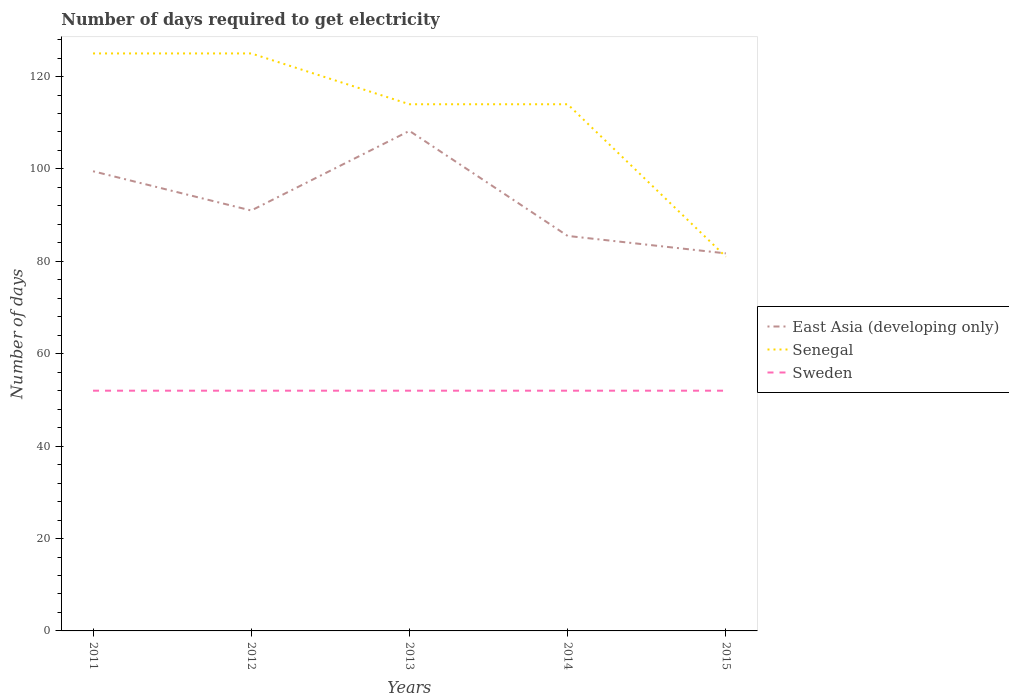How many different coloured lines are there?
Offer a very short reply. 3. Does the line corresponding to Sweden intersect with the line corresponding to Senegal?
Offer a terse response. No. Is the number of lines equal to the number of legend labels?
Ensure brevity in your answer.  Yes. Across all years, what is the maximum number of days required to get electricity in in Senegal?
Offer a very short reply. 81. What is the total number of days required to get electricity in in East Asia (developing only) in the graph?
Your answer should be very brief. 3.78. What is the difference between the highest and the second highest number of days required to get electricity in in Senegal?
Offer a terse response. 44. Is the number of days required to get electricity in in Senegal strictly greater than the number of days required to get electricity in in Sweden over the years?
Ensure brevity in your answer.  No. How many lines are there?
Make the answer very short. 3. Are the values on the major ticks of Y-axis written in scientific E-notation?
Provide a short and direct response. No. Does the graph contain any zero values?
Provide a succinct answer. No. Where does the legend appear in the graph?
Offer a terse response. Center right. What is the title of the graph?
Provide a short and direct response. Number of days required to get electricity. Does "Sri Lanka" appear as one of the legend labels in the graph?
Offer a very short reply. No. What is the label or title of the Y-axis?
Provide a succinct answer. Number of days. What is the Number of days of East Asia (developing only) in 2011?
Make the answer very short. 99.5. What is the Number of days of Senegal in 2011?
Your answer should be compact. 125. What is the Number of days in Sweden in 2011?
Offer a terse response. 52. What is the Number of days of East Asia (developing only) in 2012?
Offer a very short reply. 91. What is the Number of days in Senegal in 2012?
Your response must be concise. 125. What is the Number of days of Sweden in 2012?
Ensure brevity in your answer.  52. What is the Number of days in East Asia (developing only) in 2013?
Provide a short and direct response. 108.24. What is the Number of days of Senegal in 2013?
Your answer should be very brief. 114. What is the Number of days in Sweden in 2013?
Provide a succinct answer. 52. What is the Number of days of East Asia (developing only) in 2014?
Keep it short and to the point. 85.5. What is the Number of days in Senegal in 2014?
Ensure brevity in your answer.  114. What is the Number of days in Sweden in 2014?
Keep it short and to the point. 52. What is the Number of days of East Asia (developing only) in 2015?
Offer a very short reply. 81.72. What is the Number of days in Sweden in 2015?
Provide a succinct answer. 52. Across all years, what is the maximum Number of days of East Asia (developing only)?
Your response must be concise. 108.24. Across all years, what is the maximum Number of days of Senegal?
Your response must be concise. 125. Across all years, what is the maximum Number of days of Sweden?
Your answer should be very brief. 52. Across all years, what is the minimum Number of days in East Asia (developing only)?
Your answer should be compact. 81.72. Across all years, what is the minimum Number of days in Sweden?
Provide a short and direct response. 52. What is the total Number of days in East Asia (developing only) in the graph?
Provide a succinct answer. 465.96. What is the total Number of days of Senegal in the graph?
Offer a terse response. 559. What is the total Number of days of Sweden in the graph?
Offer a terse response. 260. What is the difference between the Number of days in East Asia (developing only) in 2011 and that in 2012?
Your response must be concise. 8.5. What is the difference between the Number of days of Senegal in 2011 and that in 2012?
Your answer should be very brief. 0. What is the difference between the Number of days in East Asia (developing only) in 2011 and that in 2013?
Your answer should be very brief. -8.74. What is the difference between the Number of days in Senegal in 2011 and that in 2013?
Keep it short and to the point. 11. What is the difference between the Number of days of East Asia (developing only) in 2011 and that in 2014?
Keep it short and to the point. 14. What is the difference between the Number of days in Senegal in 2011 and that in 2014?
Ensure brevity in your answer.  11. What is the difference between the Number of days of Sweden in 2011 and that in 2014?
Provide a short and direct response. 0. What is the difference between the Number of days in East Asia (developing only) in 2011 and that in 2015?
Your response must be concise. 17.78. What is the difference between the Number of days in Senegal in 2011 and that in 2015?
Provide a short and direct response. 44. What is the difference between the Number of days in Sweden in 2011 and that in 2015?
Provide a succinct answer. 0. What is the difference between the Number of days of East Asia (developing only) in 2012 and that in 2013?
Your answer should be very brief. -17.24. What is the difference between the Number of days in Senegal in 2012 and that in 2013?
Provide a succinct answer. 11. What is the difference between the Number of days in Sweden in 2012 and that in 2013?
Make the answer very short. 0. What is the difference between the Number of days in Senegal in 2012 and that in 2014?
Give a very brief answer. 11. What is the difference between the Number of days of East Asia (developing only) in 2012 and that in 2015?
Make the answer very short. 9.28. What is the difference between the Number of days in Sweden in 2012 and that in 2015?
Your response must be concise. 0. What is the difference between the Number of days in East Asia (developing only) in 2013 and that in 2014?
Your answer should be compact. 22.74. What is the difference between the Number of days of Senegal in 2013 and that in 2014?
Your answer should be compact. 0. What is the difference between the Number of days of Sweden in 2013 and that in 2014?
Offer a very short reply. 0. What is the difference between the Number of days in East Asia (developing only) in 2013 and that in 2015?
Provide a short and direct response. 26.51. What is the difference between the Number of days of East Asia (developing only) in 2014 and that in 2015?
Make the answer very short. 3.78. What is the difference between the Number of days in East Asia (developing only) in 2011 and the Number of days in Senegal in 2012?
Keep it short and to the point. -25.5. What is the difference between the Number of days of East Asia (developing only) in 2011 and the Number of days of Sweden in 2012?
Give a very brief answer. 47.5. What is the difference between the Number of days of Senegal in 2011 and the Number of days of Sweden in 2012?
Provide a succinct answer. 73. What is the difference between the Number of days of East Asia (developing only) in 2011 and the Number of days of Senegal in 2013?
Ensure brevity in your answer.  -14.5. What is the difference between the Number of days of East Asia (developing only) in 2011 and the Number of days of Sweden in 2013?
Ensure brevity in your answer.  47.5. What is the difference between the Number of days in East Asia (developing only) in 2011 and the Number of days in Senegal in 2014?
Keep it short and to the point. -14.5. What is the difference between the Number of days of East Asia (developing only) in 2011 and the Number of days of Sweden in 2014?
Your answer should be compact. 47.5. What is the difference between the Number of days in Senegal in 2011 and the Number of days in Sweden in 2014?
Your answer should be compact. 73. What is the difference between the Number of days in East Asia (developing only) in 2011 and the Number of days in Sweden in 2015?
Provide a short and direct response. 47.5. What is the difference between the Number of days of East Asia (developing only) in 2012 and the Number of days of Senegal in 2013?
Your answer should be very brief. -23. What is the difference between the Number of days in Senegal in 2012 and the Number of days in Sweden in 2013?
Offer a very short reply. 73. What is the difference between the Number of days in East Asia (developing only) in 2012 and the Number of days in Senegal in 2014?
Make the answer very short. -23. What is the difference between the Number of days in East Asia (developing only) in 2012 and the Number of days in Sweden in 2014?
Provide a succinct answer. 39. What is the difference between the Number of days of East Asia (developing only) in 2012 and the Number of days of Sweden in 2015?
Give a very brief answer. 39. What is the difference between the Number of days of Senegal in 2012 and the Number of days of Sweden in 2015?
Your answer should be very brief. 73. What is the difference between the Number of days in East Asia (developing only) in 2013 and the Number of days in Senegal in 2014?
Ensure brevity in your answer.  -5.76. What is the difference between the Number of days of East Asia (developing only) in 2013 and the Number of days of Sweden in 2014?
Offer a very short reply. 56.24. What is the difference between the Number of days in Senegal in 2013 and the Number of days in Sweden in 2014?
Your answer should be compact. 62. What is the difference between the Number of days in East Asia (developing only) in 2013 and the Number of days in Senegal in 2015?
Make the answer very short. 27.24. What is the difference between the Number of days in East Asia (developing only) in 2013 and the Number of days in Sweden in 2015?
Make the answer very short. 56.24. What is the difference between the Number of days of Senegal in 2013 and the Number of days of Sweden in 2015?
Provide a short and direct response. 62. What is the difference between the Number of days of East Asia (developing only) in 2014 and the Number of days of Sweden in 2015?
Your answer should be very brief. 33.5. What is the average Number of days of East Asia (developing only) per year?
Offer a very short reply. 93.19. What is the average Number of days in Senegal per year?
Your answer should be compact. 111.8. What is the average Number of days in Sweden per year?
Offer a very short reply. 52. In the year 2011, what is the difference between the Number of days of East Asia (developing only) and Number of days of Senegal?
Provide a succinct answer. -25.5. In the year 2011, what is the difference between the Number of days of East Asia (developing only) and Number of days of Sweden?
Your answer should be very brief. 47.5. In the year 2011, what is the difference between the Number of days of Senegal and Number of days of Sweden?
Offer a terse response. 73. In the year 2012, what is the difference between the Number of days of East Asia (developing only) and Number of days of Senegal?
Your answer should be compact. -34. In the year 2012, what is the difference between the Number of days of East Asia (developing only) and Number of days of Sweden?
Your answer should be very brief. 39. In the year 2013, what is the difference between the Number of days of East Asia (developing only) and Number of days of Senegal?
Ensure brevity in your answer.  -5.76. In the year 2013, what is the difference between the Number of days in East Asia (developing only) and Number of days in Sweden?
Your response must be concise. 56.24. In the year 2014, what is the difference between the Number of days of East Asia (developing only) and Number of days of Senegal?
Give a very brief answer. -28.5. In the year 2014, what is the difference between the Number of days in East Asia (developing only) and Number of days in Sweden?
Your response must be concise. 33.5. In the year 2014, what is the difference between the Number of days of Senegal and Number of days of Sweden?
Offer a very short reply. 62. In the year 2015, what is the difference between the Number of days in East Asia (developing only) and Number of days in Senegal?
Keep it short and to the point. 0.72. In the year 2015, what is the difference between the Number of days in East Asia (developing only) and Number of days in Sweden?
Your answer should be very brief. 29.72. In the year 2015, what is the difference between the Number of days of Senegal and Number of days of Sweden?
Offer a very short reply. 29. What is the ratio of the Number of days in East Asia (developing only) in 2011 to that in 2012?
Your answer should be compact. 1.09. What is the ratio of the Number of days in Senegal in 2011 to that in 2012?
Provide a succinct answer. 1. What is the ratio of the Number of days of East Asia (developing only) in 2011 to that in 2013?
Keep it short and to the point. 0.92. What is the ratio of the Number of days in Senegal in 2011 to that in 2013?
Give a very brief answer. 1.1. What is the ratio of the Number of days of Sweden in 2011 to that in 2013?
Your response must be concise. 1. What is the ratio of the Number of days in East Asia (developing only) in 2011 to that in 2014?
Ensure brevity in your answer.  1.16. What is the ratio of the Number of days in Senegal in 2011 to that in 2014?
Your answer should be compact. 1.1. What is the ratio of the Number of days of Sweden in 2011 to that in 2014?
Your response must be concise. 1. What is the ratio of the Number of days of East Asia (developing only) in 2011 to that in 2015?
Give a very brief answer. 1.22. What is the ratio of the Number of days in Senegal in 2011 to that in 2015?
Provide a succinct answer. 1.54. What is the ratio of the Number of days in Sweden in 2011 to that in 2015?
Provide a short and direct response. 1. What is the ratio of the Number of days of East Asia (developing only) in 2012 to that in 2013?
Keep it short and to the point. 0.84. What is the ratio of the Number of days in Senegal in 2012 to that in 2013?
Give a very brief answer. 1.1. What is the ratio of the Number of days in Sweden in 2012 to that in 2013?
Your response must be concise. 1. What is the ratio of the Number of days of East Asia (developing only) in 2012 to that in 2014?
Your response must be concise. 1.06. What is the ratio of the Number of days in Senegal in 2012 to that in 2014?
Provide a succinct answer. 1.1. What is the ratio of the Number of days of Sweden in 2012 to that in 2014?
Offer a terse response. 1. What is the ratio of the Number of days in East Asia (developing only) in 2012 to that in 2015?
Make the answer very short. 1.11. What is the ratio of the Number of days of Senegal in 2012 to that in 2015?
Provide a succinct answer. 1.54. What is the ratio of the Number of days in Sweden in 2012 to that in 2015?
Ensure brevity in your answer.  1. What is the ratio of the Number of days in East Asia (developing only) in 2013 to that in 2014?
Keep it short and to the point. 1.27. What is the ratio of the Number of days of East Asia (developing only) in 2013 to that in 2015?
Your answer should be very brief. 1.32. What is the ratio of the Number of days of Senegal in 2013 to that in 2015?
Make the answer very short. 1.41. What is the ratio of the Number of days in East Asia (developing only) in 2014 to that in 2015?
Make the answer very short. 1.05. What is the ratio of the Number of days in Senegal in 2014 to that in 2015?
Offer a very short reply. 1.41. What is the difference between the highest and the second highest Number of days in East Asia (developing only)?
Offer a very short reply. 8.74. What is the difference between the highest and the second highest Number of days of Senegal?
Provide a short and direct response. 0. What is the difference between the highest and the lowest Number of days of East Asia (developing only)?
Offer a very short reply. 26.51. 